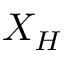Convert formula to latex. <formula><loc_0><loc_0><loc_500><loc_500>X _ { H }</formula> 